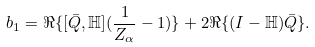<formula> <loc_0><loc_0><loc_500><loc_500>b _ { 1 } = \Re \{ [ \bar { Q } , \mathbb { H } ] ( \frac { 1 } { Z _ { \alpha } } - 1 ) \} + 2 \Re \{ ( I - \mathbb { H } ) \bar { Q } \} .</formula> 